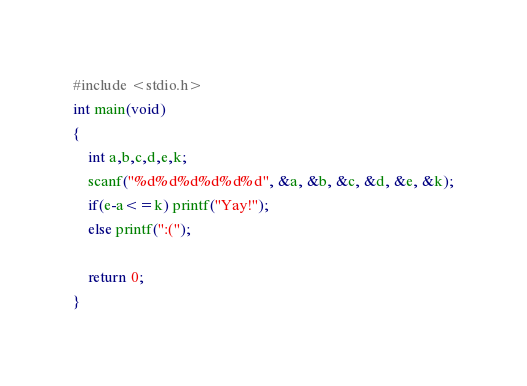Convert code to text. <code><loc_0><loc_0><loc_500><loc_500><_C_>#include <stdio.h>
int main(void)
{
	int a,b,c,d,e,k;
	scanf("%d%d%d%d%d%d", &a, &b, &c, &d, &e, &k);
	if(e-a<=k) printf("Yay!");
 	else printf(":(");
  
  	return 0;
}</code> 